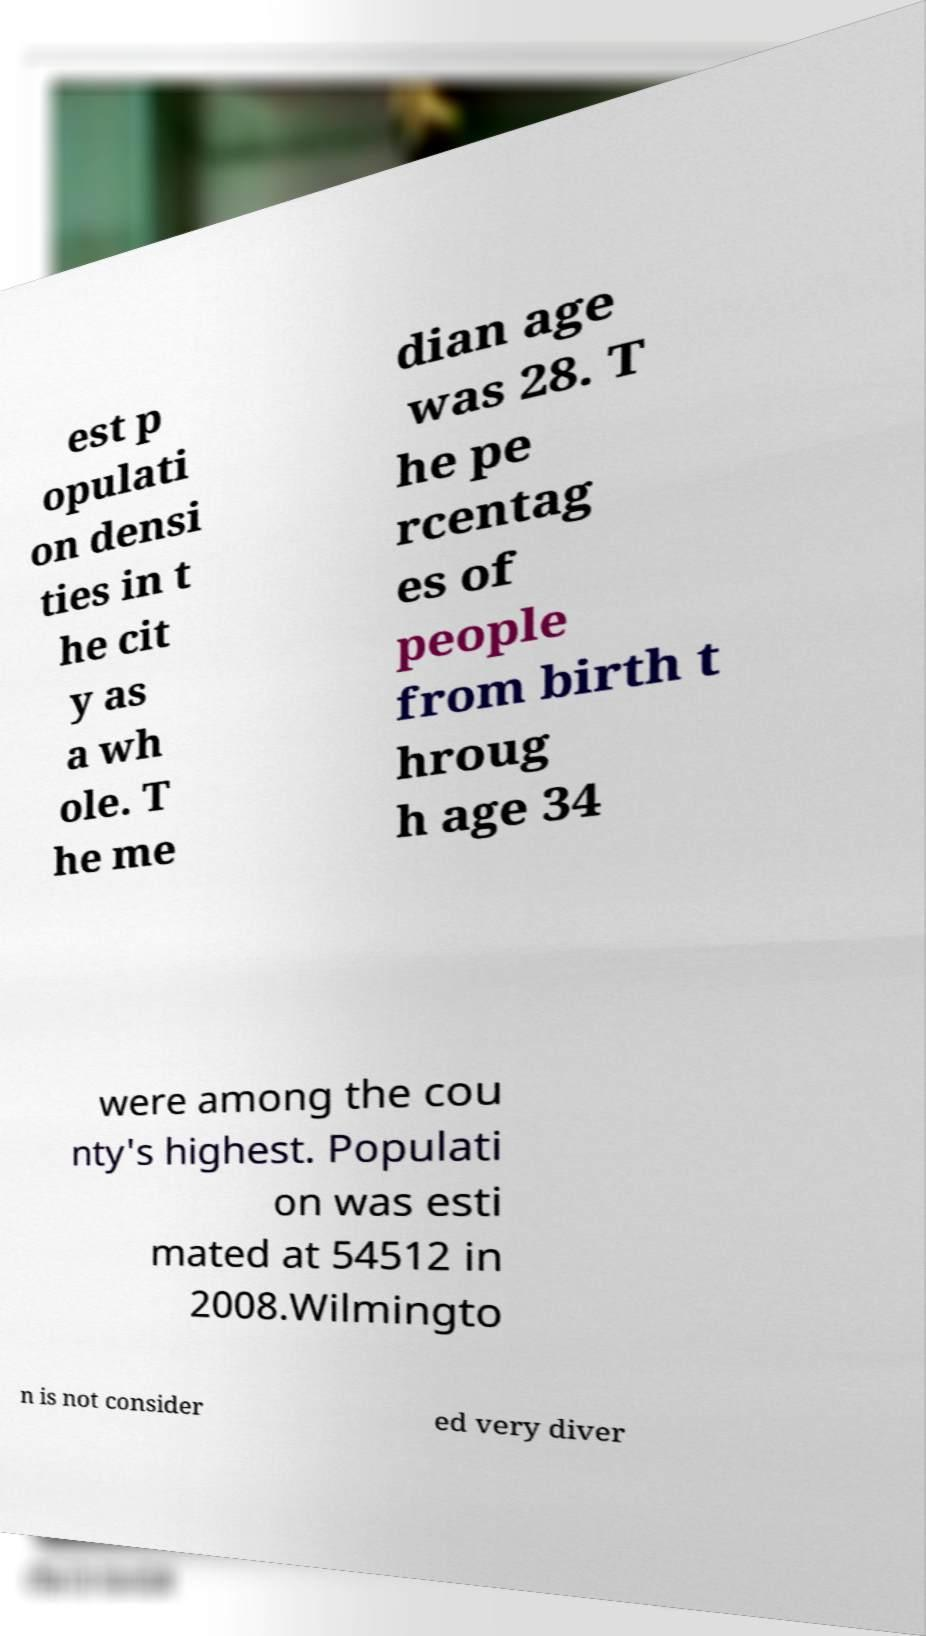For documentation purposes, I need the text within this image transcribed. Could you provide that? est p opulati on densi ties in t he cit y as a wh ole. T he me dian age was 28. T he pe rcentag es of people from birth t hroug h age 34 were among the cou nty's highest. Populati on was esti mated at 54512 in 2008.Wilmingto n is not consider ed very diver 